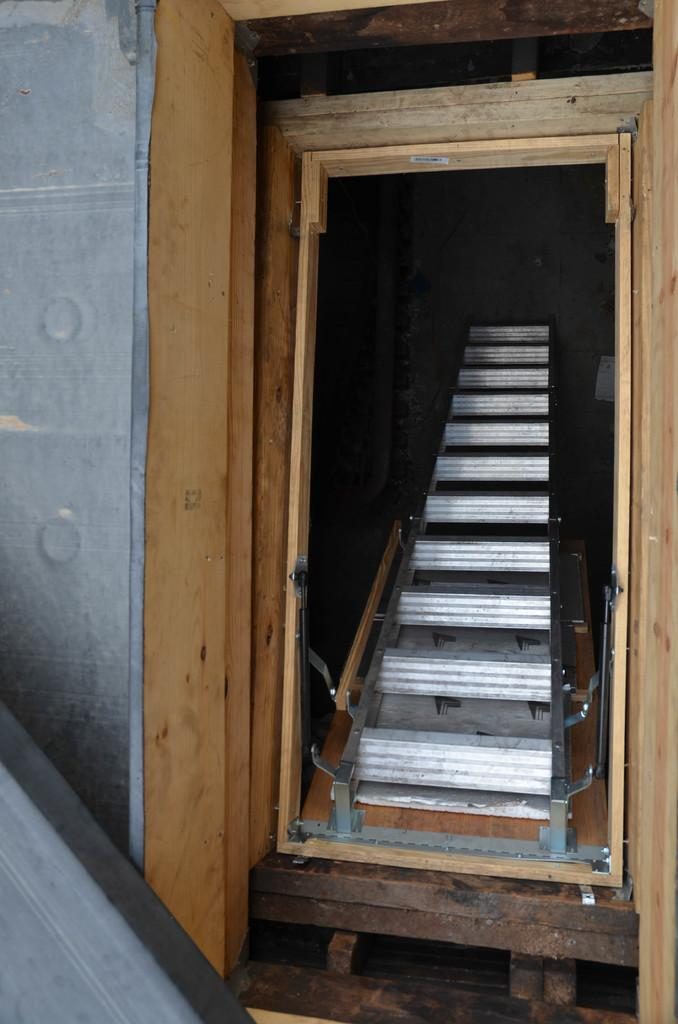What type of structure can be seen in the image? There is a wooden frame in the image. What is the wooden frame likely used for? The wooden frame might be used for supporting or holding something, but the specific purpose is not clear from the image. Are there any other objects visible in the image? Yes, there is a ladder in the image. What might the ladder be used for in conjunction with the wooden frame? The ladder could be used to reach or access something that is higher up or inside the wooden frame. What type of seat is visible in the image? There is no seat present in the image; it only features a wooden frame and a ladder. 